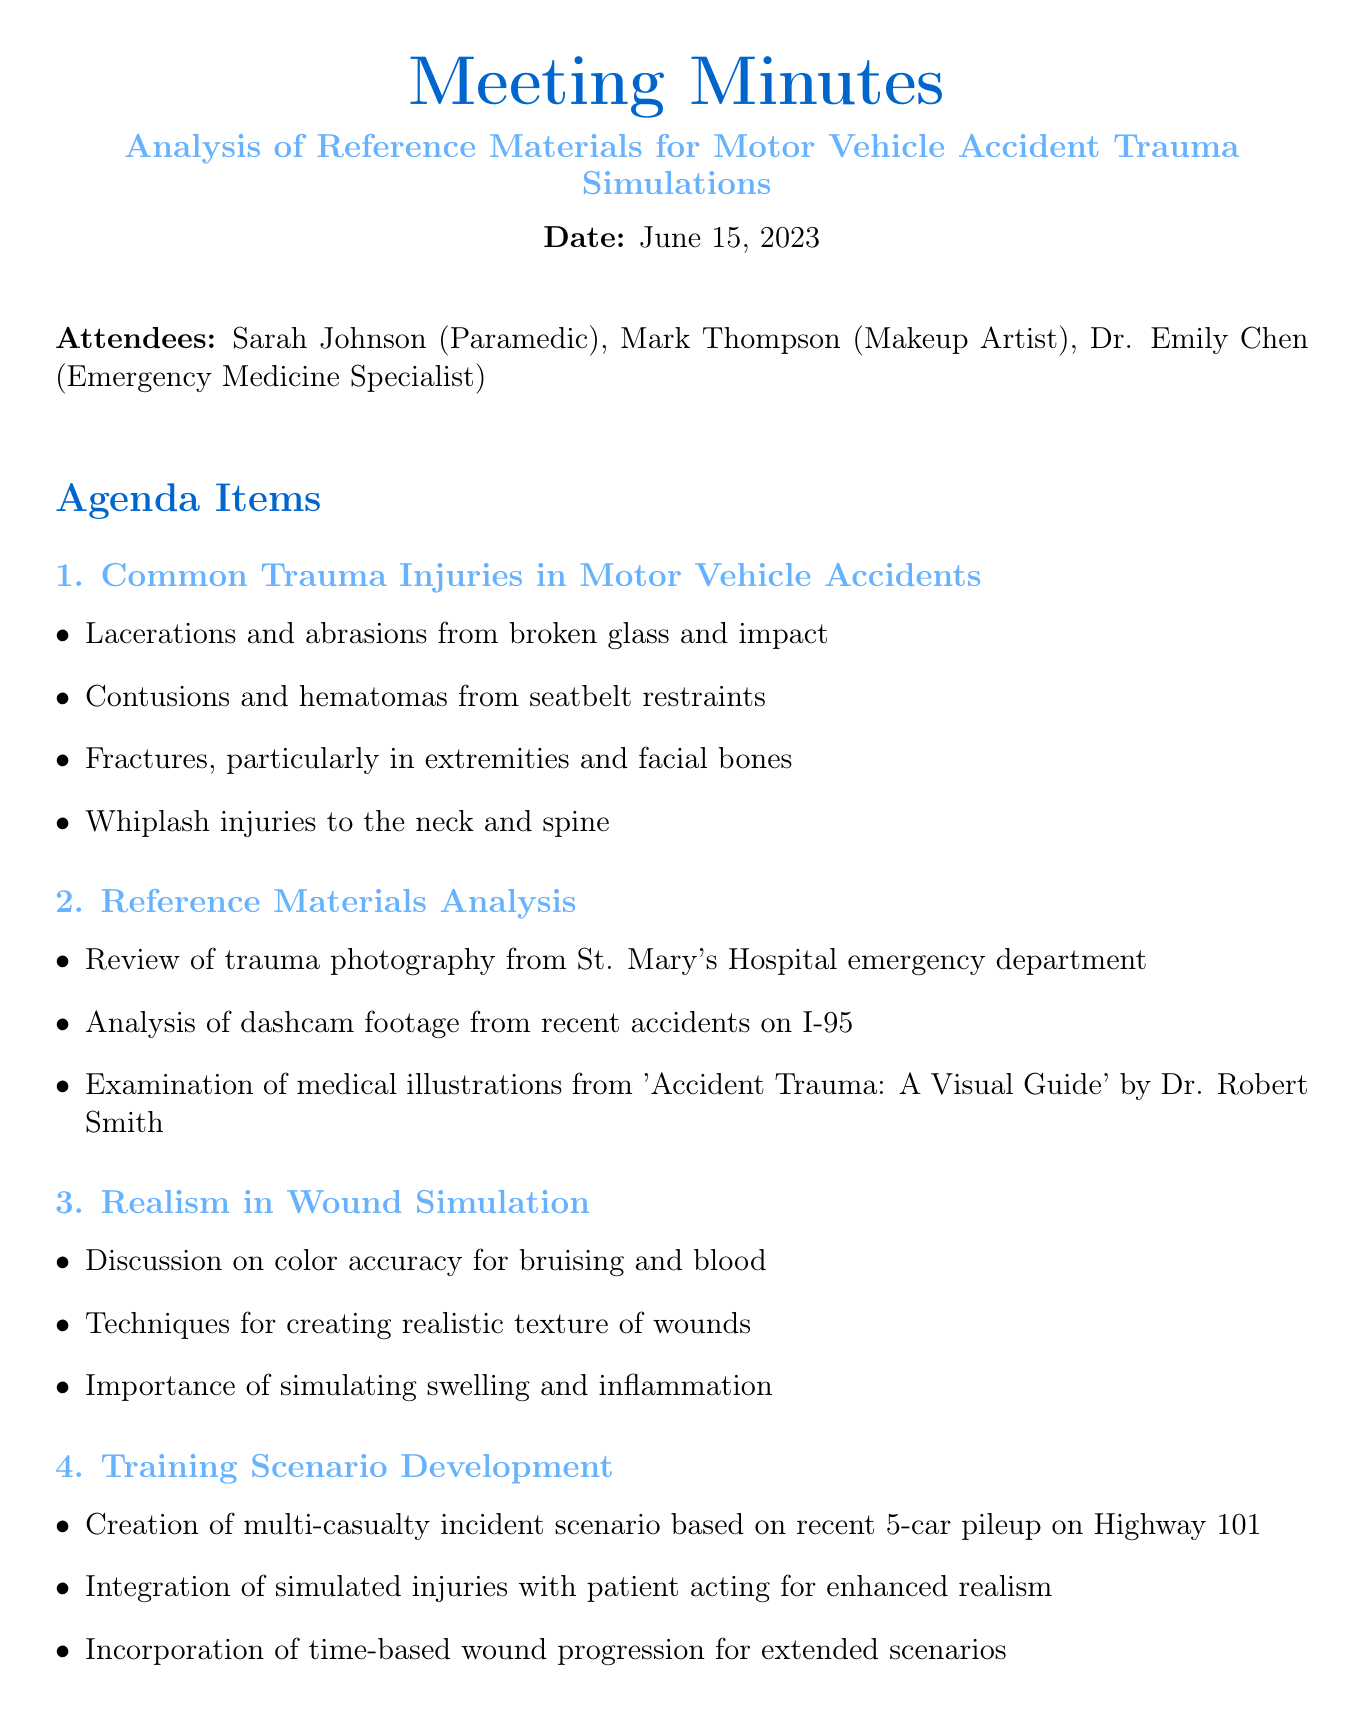What is the date of the meeting? The date of the meeting is mentioned in the document as June 15, 2023.
Answer: June 15, 2023 Who presented the reference materials analysis? The minutes list the attendees but do not specify who presented; however, it contains the collective analysis of attendees.
Answer: N/A What is one of the trauma injuries discussed in the meeting? The document outlines several trauma injuries common in motor vehicle accidents, including lacerations and abrasions.
Answer: Lacerations and abrasions What is the next meeting date? The next meeting is scheduled for June 29, 2023, as listed at the end of the document.
Answer: June 29, 2023 Which hospital's photography was reviewed? The document specifies that trauma photography from St. Mary's Hospital emergency department was reviewed.
Answer: St. Mary's Hospital What is one of the action items listed for Mark? The action items include that Mark should research new silicone compounds for improved wound texture.
Answer: Research new silicone compounds How many agenda items were discussed? The document lists four distinct agenda items regarding various topics of analysis and training.
Answer: Four What type of scenario is being developed? The document describes the creation of a multi-casualty incident scenario based on a recent 5-car pileup.
Answer: Multi-casualty incident scenario What topic is emphasized in the realism in wound simulation discussion? The discussions emphasize the importance of color accuracy for bruising and blood in simulations.
Answer: Color accuracy 